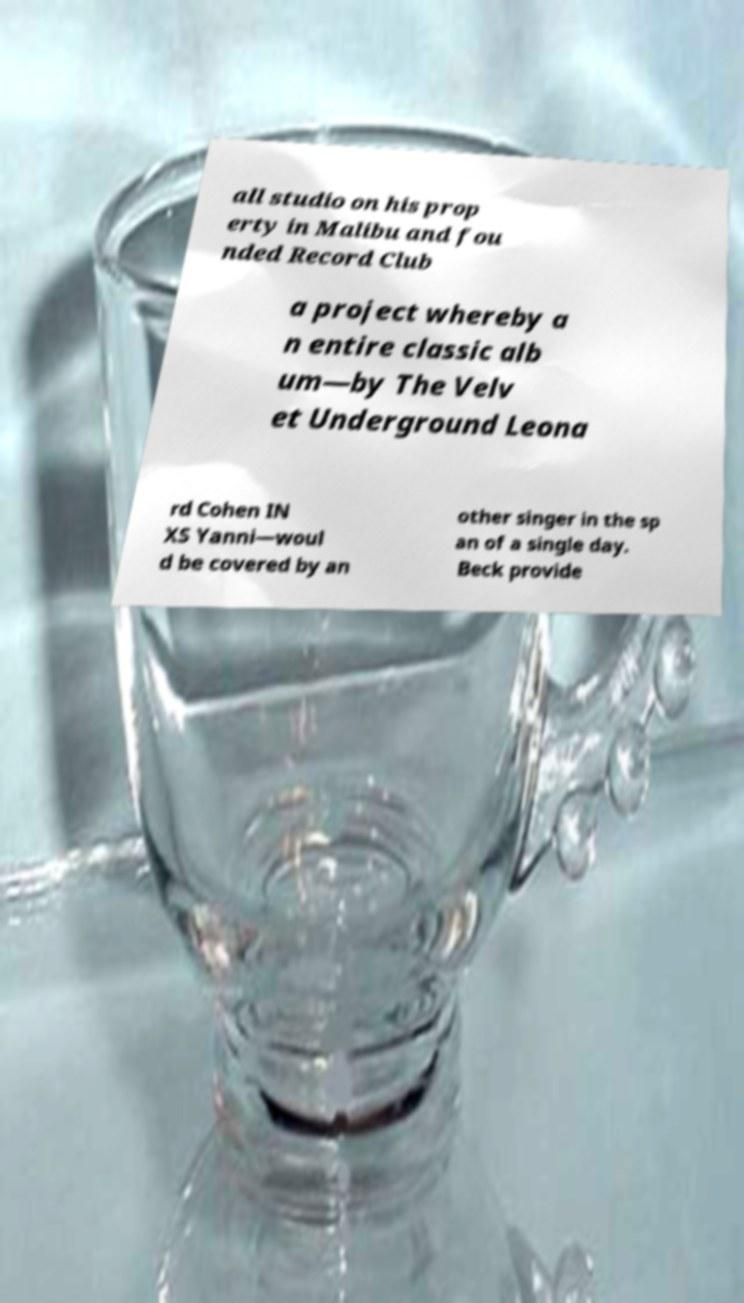Please read and relay the text visible in this image. What does it say? all studio on his prop erty in Malibu and fou nded Record Club a project whereby a n entire classic alb um—by The Velv et Underground Leona rd Cohen IN XS Yanni—woul d be covered by an other singer in the sp an of a single day. Beck provide 